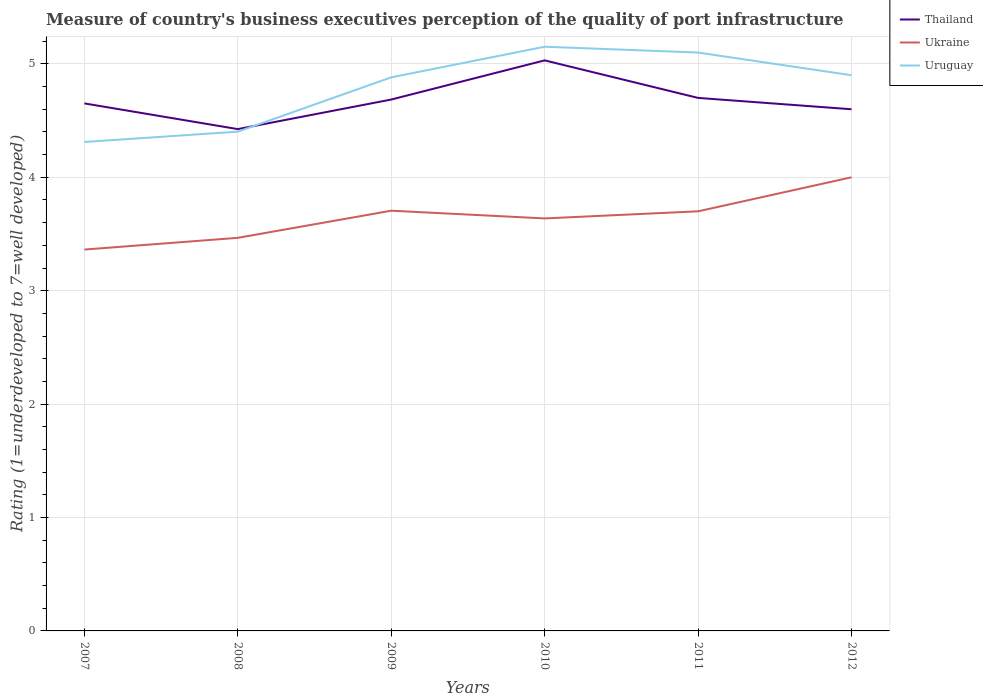How many different coloured lines are there?
Offer a very short reply. 3. Does the line corresponding to Uruguay intersect with the line corresponding to Thailand?
Your response must be concise. Yes. Across all years, what is the maximum ratings of the quality of port infrastructure in Thailand?
Keep it short and to the point. 4.42. What is the total ratings of the quality of port infrastructure in Uruguay in the graph?
Offer a very short reply. -0.59. What is the difference between the highest and the second highest ratings of the quality of port infrastructure in Uruguay?
Keep it short and to the point. 0.84. How many years are there in the graph?
Make the answer very short. 6. What is the difference between two consecutive major ticks on the Y-axis?
Keep it short and to the point. 1. Does the graph contain any zero values?
Your answer should be compact. No. Does the graph contain grids?
Offer a very short reply. Yes. How many legend labels are there?
Your answer should be very brief. 3. How are the legend labels stacked?
Make the answer very short. Vertical. What is the title of the graph?
Your answer should be compact. Measure of country's business executives perception of the quality of port infrastructure. Does "Comoros" appear as one of the legend labels in the graph?
Make the answer very short. No. What is the label or title of the Y-axis?
Your response must be concise. Rating (1=underdeveloped to 7=well developed). What is the Rating (1=underdeveloped to 7=well developed) of Thailand in 2007?
Provide a short and direct response. 4.65. What is the Rating (1=underdeveloped to 7=well developed) of Ukraine in 2007?
Provide a succinct answer. 3.36. What is the Rating (1=underdeveloped to 7=well developed) in Uruguay in 2007?
Make the answer very short. 4.31. What is the Rating (1=underdeveloped to 7=well developed) of Thailand in 2008?
Keep it short and to the point. 4.42. What is the Rating (1=underdeveloped to 7=well developed) in Ukraine in 2008?
Provide a succinct answer. 3.47. What is the Rating (1=underdeveloped to 7=well developed) of Uruguay in 2008?
Ensure brevity in your answer.  4.4. What is the Rating (1=underdeveloped to 7=well developed) in Thailand in 2009?
Ensure brevity in your answer.  4.69. What is the Rating (1=underdeveloped to 7=well developed) in Ukraine in 2009?
Offer a very short reply. 3.71. What is the Rating (1=underdeveloped to 7=well developed) of Uruguay in 2009?
Offer a very short reply. 4.88. What is the Rating (1=underdeveloped to 7=well developed) in Thailand in 2010?
Make the answer very short. 5.03. What is the Rating (1=underdeveloped to 7=well developed) of Ukraine in 2010?
Offer a terse response. 3.64. What is the Rating (1=underdeveloped to 7=well developed) in Uruguay in 2010?
Offer a very short reply. 5.15. What is the Rating (1=underdeveloped to 7=well developed) of Thailand in 2011?
Your response must be concise. 4.7. What is the Rating (1=underdeveloped to 7=well developed) of Ukraine in 2011?
Offer a very short reply. 3.7. What is the Rating (1=underdeveloped to 7=well developed) in Uruguay in 2011?
Provide a succinct answer. 5.1. What is the Rating (1=underdeveloped to 7=well developed) in Ukraine in 2012?
Offer a terse response. 4. What is the Rating (1=underdeveloped to 7=well developed) in Uruguay in 2012?
Your answer should be very brief. 4.9. Across all years, what is the maximum Rating (1=underdeveloped to 7=well developed) in Thailand?
Your response must be concise. 5.03. Across all years, what is the maximum Rating (1=underdeveloped to 7=well developed) of Uruguay?
Keep it short and to the point. 5.15. Across all years, what is the minimum Rating (1=underdeveloped to 7=well developed) of Thailand?
Make the answer very short. 4.42. Across all years, what is the minimum Rating (1=underdeveloped to 7=well developed) of Ukraine?
Make the answer very short. 3.36. Across all years, what is the minimum Rating (1=underdeveloped to 7=well developed) in Uruguay?
Ensure brevity in your answer.  4.31. What is the total Rating (1=underdeveloped to 7=well developed) of Thailand in the graph?
Offer a terse response. 28.09. What is the total Rating (1=underdeveloped to 7=well developed) in Ukraine in the graph?
Make the answer very short. 21.87. What is the total Rating (1=underdeveloped to 7=well developed) in Uruguay in the graph?
Give a very brief answer. 28.75. What is the difference between the Rating (1=underdeveloped to 7=well developed) in Thailand in 2007 and that in 2008?
Give a very brief answer. 0.23. What is the difference between the Rating (1=underdeveloped to 7=well developed) in Ukraine in 2007 and that in 2008?
Provide a short and direct response. -0.1. What is the difference between the Rating (1=underdeveloped to 7=well developed) of Uruguay in 2007 and that in 2008?
Provide a short and direct response. -0.09. What is the difference between the Rating (1=underdeveloped to 7=well developed) in Thailand in 2007 and that in 2009?
Offer a terse response. -0.03. What is the difference between the Rating (1=underdeveloped to 7=well developed) in Ukraine in 2007 and that in 2009?
Make the answer very short. -0.34. What is the difference between the Rating (1=underdeveloped to 7=well developed) in Uruguay in 2007 and that in 2009?
Offer a very short reply. -0.57. What is the difference between the Rating (1=underdeveloped to 7=well developed) of Thailand in 2007 and that in 2010?
Keep it short and to the point. -0.38. What is the difference between the Rating (1=underdeveloped to 7=well developed) of Ukraine in 2007 and that in 2010?
Keep it short and to the point. -0.27. What is the difference between the Rating (1=underdeveloped to 7=well developed) of Uruguay in 2007 and that in 2010?
Offer a terse response. -0.84. What is the difference between the Rating (1=underdeveloped to 7=well developed) of Thailand in 2007 and that in 2011?
Make the answer very short. -0.05. What is the difference between the Rating (1=underdeveloped to 7=well developed) in Ukraine in 2007 and that in 2011?
Provide a succinct answer. -0.34. What is the difference between the Rating (1=underdeveloped to 7=well developed) in Uruguay in 2007 and that in 2011?
Your response must be concise. -0.79. What is the difference between the Rating (1=underdeveloped to 7=well developed) in Thailand in 2007 and that in 2012?
Keep it short and to the point. 0.05. What is the difference between the Rating (1=underdeveloped to 7=well developed) in Ukraine in 2007 and that in 2012?
Make the answer very short. -0.64. What is the difference between the Rating (1=underdeveloped to 7=well developed) in Uruguay in 2007 and that in 2012?
Your answer should be very brief. -0.59. What is the difference between the Rating (1=underdeveloped to 7=well developed) in Thailand in 2008 and that in 2009?
Your answer should be compact. -0.26. What is the difference between the Rating (1=underdeveloped to 7=well developed) in Ukraine in 2008 and that in 2009?
Ensure brevity in your answer.  -0.24. What is the difference between the Rating (1=underdeveloped to 7=well developed) of Uruguay in 2008 and that in 2009?
Keep it short and to the point. -0.48. What is the difference between the Rating (1=underdeveloped to 7=well developed) in Thailand in 2008 and that in 2010?
Make the answer very short. -0.61. What is the difference between the Rating (1=underdeveloped to 7=well developed) of Ukraine in 2008 and that in 2010?
Make the answer very short. -0.17. What is the difference between the Rating (1=underdeveloped to 7=well developed) in Uruguay in 2008 and that in 2010?
Your answer should be compact. -0.75. What is the difference between the Rating (1=underdeveloped to 7=well developed) of Thailand in 2008 and that in 2011?
Your answer should be very brief. -0.28. What is the difference between the Rating (1=underdeveloped to 7=well developed) in Ukraine in 2008 and that in 2011?
Your answer should be very brief. -0.23. What is the difference between the Rating (1=underdeveloped to 7=well developed) of Uruguay in 2008 and that in 2011?
Offer a very short reply. -0.7. What is the difference between the Rating (1=underdeveloped to 7=well developed) of Thailand in 2008 and that in 2012?
Keep it short and to the point. -0.18. What is the difference between the Rating (1=underdeveloped to 7=well developed) in Ukraine in 2008 and that in 2012?
Offer a terse response. -0.53. What is the difference between the Rating (1=underdeveloped to 7=well developed) of Uruguay in 2008 and that in 2012?
Provide a short and direct response. -0.5. What is the difference between the Rating (1=underdeveloped to 7=well developed) in Thailand in 2009 and that in 2010?
Provide a short and direct response. -0.35. What is the difference between the Rating (1=underdeveloped to 7=well developed) in Ukraine in 2009 and that in 2010?
Your answer should be very brief. 0.07. What is the difference between the Rating (1=underdeveloped to 7=well developed) in Uruguay in 2009 and that in 2010?
Offer a terse response. -0.27. What is the difference between the Rating (1=underdeveloped to 7=well developed) of Thailand in 2009 and that in 2011?
Give a very brief answer. -0.01. What is the difference between the Rating (1=underdeveloped to 7=well developed) in Ukraine in 2009 and that in 2011?
Offer a very short reply. 0.01. What is the difference between the Rating (1=underdeveloped to 7=well developed) in Uruguay in 2009 and that in 2011?
Give a very brief answer. -0.22. What is the difference between the Rating (1=underdeveloped to 7=well developed) in Thailand in 2009 and that in 2012?
Provide a succinct answer. 0.09. What is the difference between the Rating (1=underdeveloped to 7=well developed) in Ukraine in 2009 and that in 2012?
Give a very brief answer. -0.29. What is the difference between the Rating (1=underdeveloped to 7=well developed) in Uruguay in 2009 and that in 2012?
Ensure brevity in your answer.  -0.02. What is the difference between the Rating (1=underdeveloped to 7=well developed) in Thailand in 2010 and that in 2011?
Provide a succinct answer. 0.33. What is the difference between the Rating (1=underdeveloped to 7=well developed) of Ukraine in 2010 and that in 2011?
Your response must be concise. -0.06. What is the difference between the Rating (1=underdeveloped to 7=well developed) in Uruguay in 2010 and that in 2011?
Your answer should be compact. 0.05. What is the difference between the Rating (1=underdeveloped to 7=well developed) of Thailand in 2010 and that in 2012?
Give a very brief answer. 0.43. What is the difference between the Rating (1=underdeveloped to 7=well developed) of Ukraine in 2010 and that in 2012?
Provide a succinct answer. -0.36. What is the difference between the Rating (1=underdeveloped to 7=well developed) in Uruguay in 2010 and that in 2012?
Your response must be concise. 0.25. What is the difference between the Rating (1=underdeveloped to 7=well developed) in Ukraine in 2011 and that in 2012?
Keep it short and to the point. -0.3. What is the difference between the Rating (1=underdeveloped to 7=well developed) in Uruguay in 2011 and that in 2012?
Your answer should be compact. 0.2. What is the difference between the Rating (1=underdeveloped to 7=well developed) in Thailand in 2007 and the Rating (1=underdeveloped to 7=well developed) in Ukraine in 2008?
Provide a short and direct response. 1.19. What is the difference between the Rating (1=underdeveloped to 7=well developed) of Thailand in 2007 and the Rating (1=underdeveloped to 7=well developed) of Uruguay in 2008?
Ensure brevity in your answer.  0.25. What is the difference between the Rating (1=underdeveloped to 7=well developed) of Ukraine in 2007 and the Rating (1=underdeveloped to 7=well developed) of Uruguay in 2008?
Your answer should be very brief. -1.04. What is the difference between the Rating (1=underdeveloped to 7=well developed) in Thailand in 2007 and the Rating (1=underdeveloped to 7=well developed) in Ukraine in 2009?
Provide a short and direct response. 0.95. What is the difference between the Rating (1=underdeveloped to 7=well developed) of Thailand in 2007 and the Rating (1=underdeveloped to 7=well developed) of Uruguay in 2009?
Your answer should be compact. -0.23. What is the difference between the Rating (1=underdeveloped to 7=well developed) in Ukraine in 2007 and the Rating (1=underdeveloped to 7=well developed) in Uruguay in 2009?
Ensure brevity in your answer.  -1.52. What is the difference between the Rating (1=underdeveloped to 7=well developed) in Thailand in 2007 and the Rating (1=underdeveloped to 7=well developed) in Ukraine in 2010?
Your answer should be very brief. 1.01. What is the difference between the Rating (1=underdeveloped to 7=well developed) in Thailand in 2007 and the Rating (1=underdeveloped to 7=well developed) in Uruguay in 2010?
Provide a succinct answer. -0.5. What is the difference between the Rating (1=underdeveloped to 7=well developed) in Ukraine in 2007 and the Rating (1=underdeveloped to 7=well developed) in Uruguay in 2010?
Give a very brief answer. -1.79. What is the difference between the Rating (1=underdeveloped to 7=well developed) of Thailand in 2007 and the Rating (1=underdeveloped to 7=well developed) of Ukraine in 2011?
Make the answer very short. 0.95. What is the difference between the Rating (1=underdeveloped to 7=well developed) in Thailand in 2007 and the Rating (1=underdeveloped to 7=well developed) in Uruguay in 2011?
Offer a very short reply. -0.45. What is the difference between the Rating (1=underdeveloped to 7=well developed) in Ukraine in 2007 and the Rating (1=underdeveloped to 7=well developed) in Uruguay in 2011?
Make the answer very short. -1.74. What is the difference between the Rating (1=underdeveloped to 7=well developed) in Thailand in 2007 and the Rating (1=underdeveloped to 7=well developed) in Ukraine in 2012?
Give a very brief answer. 0.65. What is the difference between the Rating (1=underdeveloped to 7=well developed) in Thailand in 2007 and the Rating (1=underdeveloped to 7=well developed) in Uruguay in 2012?
Provide a succinct answer. -0.25. What is the difference between the Rating (1=underdeveloped to 7=well developed) in Ukraine in 2007 and the Rating (1=underdeveloped to 7=well developed) in Uruguay in 2012?
Provide a short and direct response. -1.54. What is the difference between the Rating (1=underdeveloped to 7=well developed) in Thailand in 2008 and the Rating (1=underdeveloped to 7=well developed) in Ukraine in 2009?
Give a very brief answer. 0.72. What is the difference between the Rating (1=underdeveloped to 7=well developed) in Thailand in 2008 and the Rating (1=underdeveloped to 7=well developed) in Uruguay in 2009?
Keep it short and to the point. -0.46. What is the difference between the Rating (1=underdeveloped to 7=well developed) in Ukraine in 2008 and the Rating (1=underdeveloped to 7=well developed) in Uruguay in 2009?
Offer a terse response. -1.42. What is the difference between the Rating (1=underdeveloped to 7=well developed) in Thailand in 2008 and the Rating (1=underdeveloped to 7=well developed) in Ukraine in 2010?
Provide a short and direct response. 0.79. What is the difference between the Rating (1=underdeveloped to 7=well developed) of Thailand in 2008 and the Rating (1=underdeveloped to 7=well developed) of Uruguay in 2010?
Provide a succinct answer. -0.73. What is the difference between the Rating (1=underdeveloped to 7=well developed) in Ukraine in 2008 and the Rating (1=underdeveloped to 7=well developed) in Uruguay in 2010?
Ensure brevity in your answer.  -1.69. What is the difference between the Rating (1=underdeveloped to 7=well developed) of Thailand in 2008 and the Rating (1=underdeveloped to 7=well developed) of Ukraine in 2011?
Ensure brevity in your answer.  0.72. What is the difference between the Rating (1=underdeveloped to 7=well developed) of Thailand in 2008 and the Rating (1=underdeveloped to 7=well developed) of Uruguay in 2011?
Provide a short and direct response. -0.68. What is the difference between the Rating (1=underdeveloped to 7=well developed) in Ukraine in 2008 and the Rating (1=underdeveloped to 7=well developed) in Uruguay in 2011?
Give a very brief answer. -1.63. What is the difference between the Rating (1=underdeveloped to 7=well developed) in Thailand in 2008 and the Rating (1=underdeveloped to 7=well developed) in Ukraine in 2012?
Offer a very short reply. 0.42. What is the difference between the Rating (1=underdeveloped to 7=well developed) in Thailand in 2008 and the Rating (1=underdeveloped to 7=well developed) in Uruguay in 2012?
Make the answer very short. -0.48. What is the difference between the Rating (1=underdeveloped to 7=well developed) in Ukraine in 2008 and the Rating (1=underdeveloped to 7=well developed) in Uruguay in 2012?
Your answer should be compact. -1.43. What is the difference between the Rating (1=underdeveloped to 7=well developed) of Thailand in 2009 and the Rating (1=underdeveloped to 7=well developed) of Ukraine in 2010?
Your answer should be very brief. 1.05. What is the difference between the Rating (1=underdeveloped to 7=well developed) in Thailand in 2009 and the Rating (1=underdeveloped to 7=well developed) in Uruguay in 2010?
Provide a succinct answer. -0.47. What is the difference between the Rating (1=underdeveloped to 7=well developed) of Ukraine in 2009 and the Rating (1=underdeveloped to 7=well developed) of Uruguay in 2010?
Your answer should be compact. -1.45. What is the difference between the Rating (1=underdeveloped to 7=well developed) in Thailand in 2009 and the Rating (1=underdeveloped to 7=well developed) in Ukraine in 2011?
Provide a short and direct response. 0.99. What is the difference between the Rating (1=underdeveloped to 7=well developed) in Thailand in 2009 and the Rating (1=underdeveloped to 7=well developed) in Uruguay in 2011?
Make the answer very short. -0.41. What is the difference between the Rating (1=underdeveloped to 7=well developed) of Ukraine in 2009 and the Rating (1=underdeveloped to 7=well developed) of Uruguay in 2011?
Give a very brief answer. -1.39. What is the difference between the Rating (1=underdeveloped to 7=well developed) in Thailand in 2009 and the Rating (1=underdeveloped to 7=well developed) in Ukraine in 2012?
Ensure brevity in your answer.  0.69. What is the difference between the Rating (1=underdeveloped to 7=well developed) in Thailand in 2009 and the Rating (1=underdeveloped to 7=well developed) in Uruguay in 2012?
Offer a very short reply. -0.21. What is the difference between the Rating (1=underdeveloped to 7=well developed) in Ukraine in 2009 and the Rating (1=underdeveloped to 7=well developed) in Uruguay in 2012?
Make the answer very short. -1.19. What is the difference between the Rating (1=underdeveloped to 7=well developed) in Thailand in 2010 and the Rating (1=underdeveloped to 7=well developed) in Ukraine in 2011?
Offer a very short reply. 1.33. What is the difference between the Rating (1=underdeveloped to 7=well developed) in Thailand in 2010 and the Rating (1=underdeveloped to 7=well developed) in Uruguay in 2011?
Offer a very short reply. -0.07. What is the difference between the Rating (1=underdeveloped to 7=well developed) in Ukraine in 2010 and the Rating (1=underdeveloped to 7=well developed) in Uruguay in 2011?
Provide a succinct answer. -1.46. What is the difference between the Rating (1=underdeveloped to 7=well developed) of Thailand in 2010 and the Rating (1=underdeveloped to 7=well developed) of Ukraine in 2012?
Keep it short and to the point. 1.03. What is the difference between the Rating (1=underdeveloped to 7=well developed) of Thailand in 2010 and the Rating (1=underdeveloped to 7=well developed) of Uruguay in 2012?
Your answer should be compact. 0.13. What is the difference between the Rating (1=underdeveloped to 7=well developed) in Ukraine in 2010 and the Rating (1=underdeveloped to 7=well developed) in Uruguay in 2012?
Ensure brevity in your answer.  -1.26. What is the difference between the Rating (1=underdeveloped to 7=well developed) in Thailand in 2011 and the Rating (1=underdeveloped to 7=well developed) in Ukraine in 2012?
Keep it short and to the point. 0.7. What is the difference between the Rating (1=underdeveloped to 7=well developed) of Thailand in 2011 and the Rating (1=underdeveloped to 7=well developed) of Uruguay in 2012?
Provide a short and direct response. -0.2. What is the average Rating (1=underdeveloped to 7=well developed) in Thailand per year?
Provide a short and direct response. 4.68. What is the average Rating (1=underdeveloped to 7=well developed) of Ukraine per year?
Offer a terse response. 3.65. What is the average Rating (1=underdeveloped to 7=well developed) in Uruguay per year?
Ensure brevity in your answer.  4.79. In the year 2007, what is the difference between the Rating (1=underdeveloped to 7=well developed) of Thailand and Rating (1=underdeveloped to 7=well developed) of Ukraine?
Keep it short and to the point. 1.29. In the year 2007, what is the difference between the Rating (1=underdeveloped to 7=well developed) in Thailand and Rating (1=underdeveloped to 7=well developed) in Uruguay?
Ensure brevity in your answer.  0.34. In the year 2007, what is the difference between the Rating (1=underdeveloped to 7=well developed) in Ukraine and Rating (1=underdeveloped to 7=well developed) in Uruguay?
Your answer should be compact. -0.95. In the year 2008, what is the difference between the Rating (1=underdeveloped to 7=well developed) of Thailand and Rating (1=underdeveloped to 7=well developed) of Ukraine?
Make the answer very short. 0.96. In the year 2008, what is the difference between the Rating (1=underdeveloped to 7=well developed) in Thailand and Rating (1=underdeveloped to 7=well developed) in Uruguay?
Provide a succinct answer. 0.02. In the year 2008, what is the difference between the Rating (1=underdeveloped to 7=well developed) of Ukraine and Rating (1=underdeveloped to 7=well developed) of Uruguay?
Offer a very short reply. -0.94. In the year 2009, what is the difference between the Rating (1=underdeveloped to 7=well developed) in Thailand and Rating (1=underdeveloped to 7=well developed) in Ukraine?
Provide a succinct answer. 0.98. In the year 2009, what is the difference between the Rating (1=underdeveloped to 7=well developed) of Thailand and Rating (1=underdeveloped to 7=well developed) of Uruguay?
Provide a succinct answer. -0.2. In the year 2009, what is the difference between the Rating (1=underdeveloped to 7=well developed) in Ukraine and Rating (1=underdeveloped to 7=well developed) in Uruguay?
Give a very brief answer. -1.18. In the year 2010, what is the difference between the Rating (1=underdeveloped to 7=well developed) in Thailand and Rating (1=underdeveloped to 7=well developed) in Ukraine?
Your response must be concise. 1.39. In the year 2010, what is the difference between the Rating (1=underdeveloped to 7=well developed) of Thailand and Rating (1=underdeveloped to 7=well developed) of Uruguay?
Your response must be concise. -0.12. In the year 2010, what is the difference between the Rating (1=underdeveloped to 7=well developed) of Ukraine and Rating (1=underdeveloped to 7=well developed) of Uruguay?
Your answer should be compact. -1.51. In the year 2011, what is the difference between the Rating (1=underdeveloped to 7=well developed) of Thailand and Rating (1=underdeveloped to 7=well developed) of Ukraine?
Ensure brevity in your answer.  1. In the year 2011, what is the difference between the Rating (1=underdeveloped to 7=well developed) of Thailand and Rating (1=underdeveloped to 7=well developed) of Uruguay?
Make the answer very short. -0.4. In the year 2012, what is the difference between the Rating (1=underdeveloped to 7=well developed) in Thailand and Rating (1=underdeveloped to 7=well developed) in Ukraine?
Your answer should be very brief. 0.6. In the year 2012, what is the difference between the Rating (1=underdeveloped to 7=well developed) of Thailand and Rating (1=underdeveloped to 7=well developed) of Uruguay?
Keep it short and to the point. -0.3. What is the ratio of the Rating (1=underdeveloped to 7=well developed) in Thailand in 2007 to that in 2008?
Provide a short and direct response. 1.05. What is the ratio of the Rating (1=underdeveloped to 7=well developed) in Ukraine in 2007 to that in 2008?
Keep it short and to the point. 0.97. What is the ratio of the Rating (1=underdeveloped to 7=well developed) of Uruguay in 2007 to that in 2008?
Keep it short and to the point. 0.98. What is the ratio of the Rating (1=underdeveloped to 7=well developed) of Ukraine in 2007 to that in 2009?
Your response must be concise. 0.91. What is the ratio of the Rating (1=underdeveloped to 7=well developed) of Uruguay in 2007 to that in 2009?
Keep it short and to the point. 0.88. What is the ratio of the Rating (1=underdeveloped to 7=well developed) in Thailand in 2007 to that in 2010?
Give a very brief answer. 0.92. What is the ratio of the Rating (1=underdeveloped to 7=well developed) of Ukraine in 2007 to that in 2010?
Your answer should be very brief. 0.92. What is the ratio of the Rating (1=underdeveloped to 7=well developed) in Uruguay in 2007 to that in 2010?
Your response must be concise. 0.84. What is the ratio of the Rating (1=underdeveloped to 7=well developed) of Ukraine in 2007 to that in 2011?
Your answer should be compact. 0.91. What is the ratio of the Rating (1=underdeveloped to 7=well developed) in Uruguay in 2007 to that in 2011?
Provide a succinct answer. 0.85. What is the ratio of the Rating (1=underdeveloped to 7=well developed) in Thailand in 2007 to that in 2012?
Your response must be concise. 1.01. What is the ratio of the Rating (1=underdeveloped to 7=well developed) of Ukraine in 2007 to that in 2012?
Offer a very short reply. 0.84. What is the ratio of the Rating (1=underdeveloped to 7=well developed) of Uruguay in 2007 to that in 2012?
Give a very brief answer. 0.88. What is the ratio of the Rating (1=underdeveloped to 7=well developed) in Thailand in 2008 to that in 2009?
Give a very brief answer. 0.94. What is the ratio of the Rating (1=underdeveloped to 7=well developed) of Ukraine in 2008 to that in 2009?
Provide a short and direct response. 0.94. What is the ratio of the Rating (1=underdeveloped to 7=well developed) of Uruguay in 2008 to that in 2009?
Give a very brief answer. 0.9. What is the ratio of the Rating (1=underdeveloped to 7=well developed) of Thailand in 2008 to that in 2010?
Your response must be concise. 0.88. What is the ratio of the Rating (1=underdeveloped to 7=well developed) in Ukraine in 2008 to that in 2010?
Your response must be concise. 0.95. What is the ratio of the Rating (1=underdeveloped to 7=well developed) in Uruguay in 2008 to that in 2010?
Offer a terse response. 0.85. What is the ratio of the Rating (1=underdeveloped to 7=well developed) of Thailand in 2008 to that in 2011?
Your answer should be compact. 0.94. What is the ratio of the Rating (1=underdeveloped to 7=well developed) of Ukraine in 2008 to that in 2011?
Ensure brevity in your answer.  0.94. What is the ratio of the Rating (1=underdeveloped to 7=well developed) of Uruguay in 2008 to that in 2011?
Make the answer very short. 0.86. What is the ratio of the Rating (1=underdeveloped to 7=well developed) of Thailand in 2008 to that in 2012?
Ensure brevity in your answer.  0.96. What is the ratio of the Rating (1=underdeveloped to 7=well developed) of Ukraine in 2008 to that in 2012?
Give a very brief answer. 0.87. What is the ratio of the Rating (1=underdeveloped to 7=well developed) of Uruguay in 2008 to that in 2012?
Offer a terse response. 0.9. What is the ratio of the Rating (1=underdeveloped to 7=well developed) of Thailand in 2009 to that in 2010?
Provide a short and direct response. 0.93. What is the ratio of the Rating (1=underdeveloped to 7=well developed) of Ukraine in 2009 to that in 2010?
Your answer should be very brief. 1.02. What is the ratio of the Rating (1=underdeveloped to 7=well developed) in Uruguay in 2009 to that in 2010?
Offer a very short reply. 0.95. What is the ratio of the Rating (1=underdeveloped to 7=well developed) of Uruguay in 2009 to that in 2011?
Ensure brevity in your answer.  0.96. What is the ratio of the Rating (1=underdeveloped to 7=well developed) in Thailand in 2009 to that in 2012?
Offer a terse response. 1.02. What is the ratio of the Rating (1=underdeveloped to 7=well developed) of Ukraine in 2009 to that in 2012?
Keep it short and to the point. 0.93. What is the ratio of the Rating (1=underdeveloped to 7=well developed) in Uruguay in 2009 to that in 2012?
Your answer should be very brief. 1. What is the ratio of the Rating (1=underdeveloped to 7=well developed) of Thailand in 2010 to that in 2011?
Give a very brief answer. 1.07. What is the ratio of the Rating (1=underdeveloped to 7=well developed) in Ukraine in 2010 to that in 2011?
Make the answer very short. 0.98. What is the ratio of the Rating (1=underdeveloped to 7=well developed) in Uruguay in 2010 to that in 2011?
Provide a succinct answer. 1.01. What is the ratio of the Rating (1=underdeveloped to 7=well developed) of Thailand in 2010 to that in 2012?
Keep it short and to the point. 1.09. What is the ratio of the Rating (1=underdeveloped to 7=well developed) in Ukraine in 2010 to that in 2012?
Offer a terse response. 0.91. What is the ratio of the Rating (1=underdeveloped to 7=well developed) of Uruguay in 2010 to that in 2012?
Give a very brief answer. 1.05. What is the ratio of the Rating (1=underdeveloped to 7=well developed) of Thailand in 2011 to that in 2012?
Give a very brief answer. 1.02. What is the ratio of the Rating (1=underdeveloped to 7=well developed) of Ukraine in 2011 to that in 2012?
Your answer should be compact. 0.93. What is the ratio of the Rating (1=underdeveloped to 7=well developed) in Uruguay in 2011 to that in 2012?
Keep it short and to the point. 1.04. What is the difference between the highest and the second highest Rating (1=underdeveloped to 7=well developed) of Thailand?
Offer a terse response. 0.33. What is the difference between the highest and the second highest Rating (1=underdeveloped to 7=well developed) in Ukraine?
Ensure brevity in your answer.  0.29. What is the difference between the highest and the second highest Rating (1=underdeveloped to 7=well developed) in Uruguay?
Your answer should be compact. 0.05. What is the difference between the highest and the lowest Rating (1=underdeveloped to 7=well developed) of Thailand?
Provide a succinct answer. 0.61. What is the difference between the highest and the lowest Rating (1=underdeveloped to 7=well developed) in Ukraine?
Offer a terse response. 0.64. What is the difference between the highest and the lowest Rating (1=underdeveloped to 7=well developed) in Uruguay?
Offer a terse response. 0.84. 